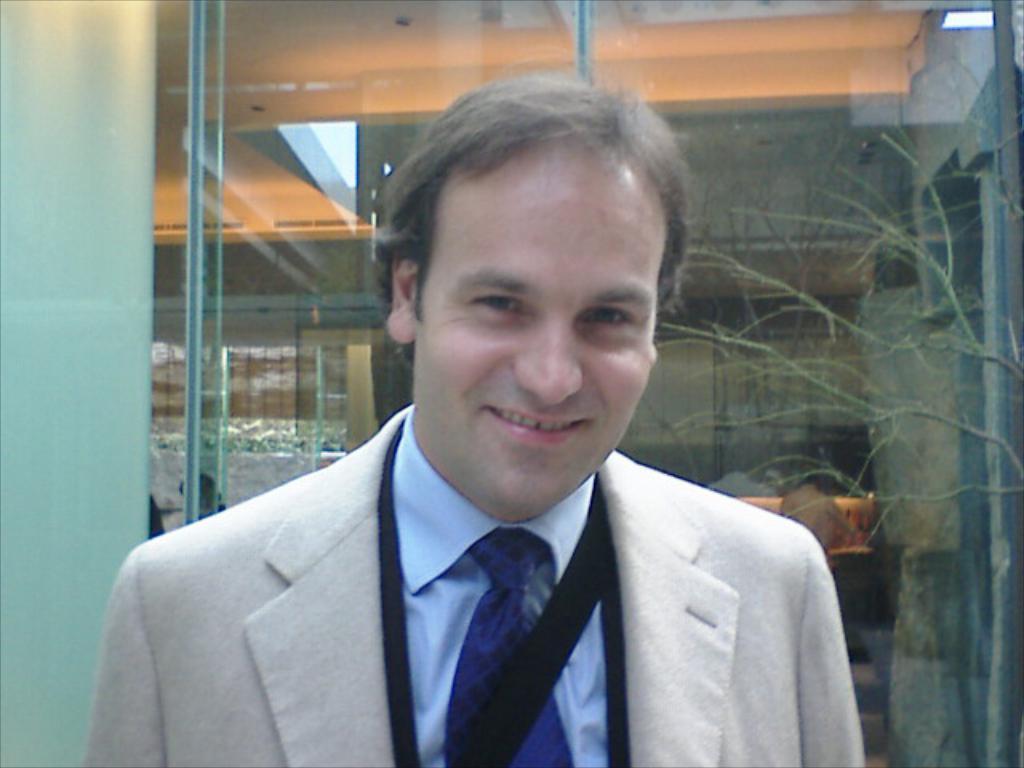Please provide a concise description of this image. In the picture we can see a man standing and smiling, he is wearing a white blazer with tie and shirt and in the background we can see a glass wall. 